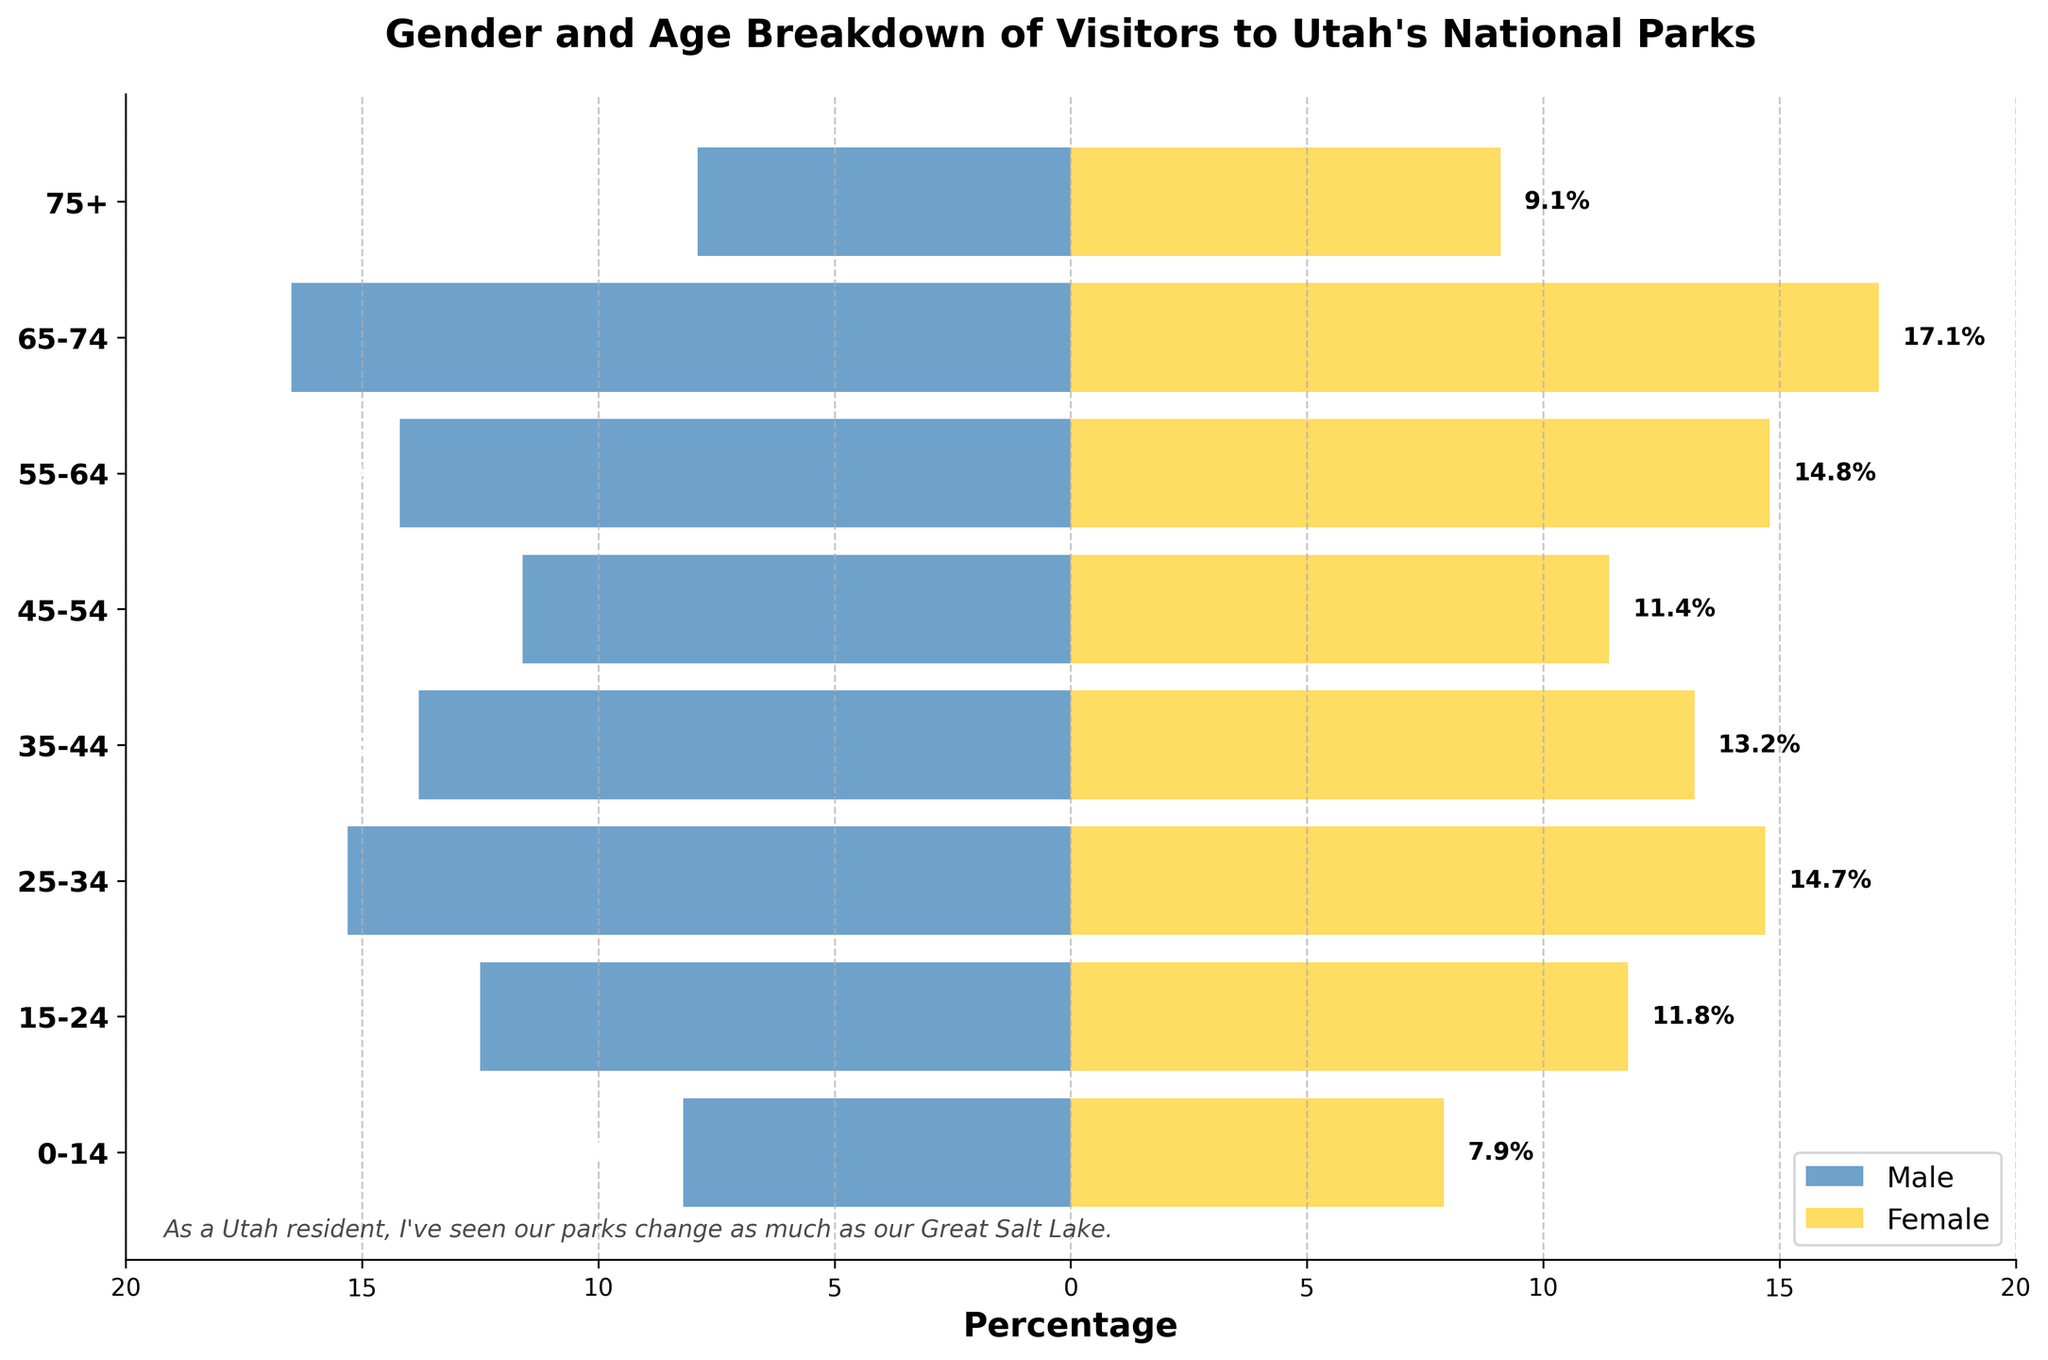Which age group has the highest percentage of female visitors? Check the female data across all age groups, and identify the group with the largest bar.
Answer: 65-74 What is the difference in percentage between male and female visitors in the 55-64 age group? Subtract the percentage of male visitors from the percentage of female visitors for the 55-64 age group: 14.8% - 14.2% = 0.6%.
Answer: 0.6% What is the total percentage of visitors in the 25-34 age group (male and female combined)? Add the percentages of male and female visitors in the 25-34 age group: 15.3% (male) + 14.7% (female) = 30%.
Answer: 30% Which age group has the smallest difference in percentage between male and female visitors? Compute the difference between male and female percentages for each age group and find the group with the smallest absolute difference. The differences are: 0-14 (0.3%), 15-24 (0.7%), 25-34 (0.6%), 35-44 (0.6%), 45-54 (0.2%), 55-64 (0.6%), 65-74 (0.6%), 75+ (1.2%). The smallest difference is in the 45-54 age group.
Answer: 45-54 In which age group do males outnumber females? Compare the percentages for males and females in each age group. Males have a higher percentage in the following groups: 0-14 (0.3% more), 15-24 (0.7% more), 25-34 (0.6% more), 35-44 (0.6% more), 45-54 (0.2% more), and 55-64 (males 0.6% less). Females outnumber males in the 55-64, 65-74, and 75+ age groups.
Answer: 0-14, 15-24, 25-34, 35-44, 45-54 